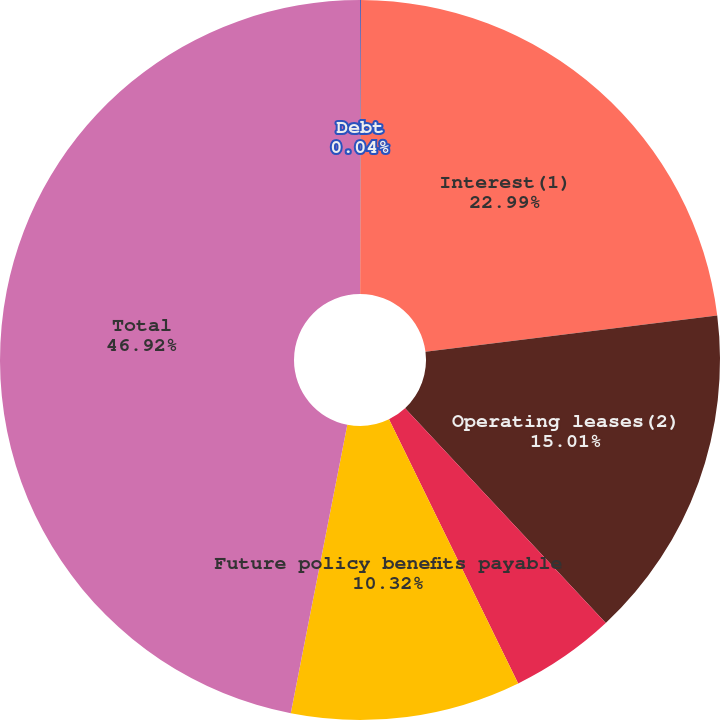<chart> <loc_0><loc_0><loc_500><loc_500><pie_chart><fcel>Debt<fcel>Interest(1)<fcel>Operating leases(2)<fcel>Purchase obligations(3)<fcel>Future policy benefits payable<fcel>Total<nl><fcel>0.04%<fcel>22.99%<fcel>15.01%<fcel>4.72%<fcel>10.32%<fcel>46.92%<nl></chart> 